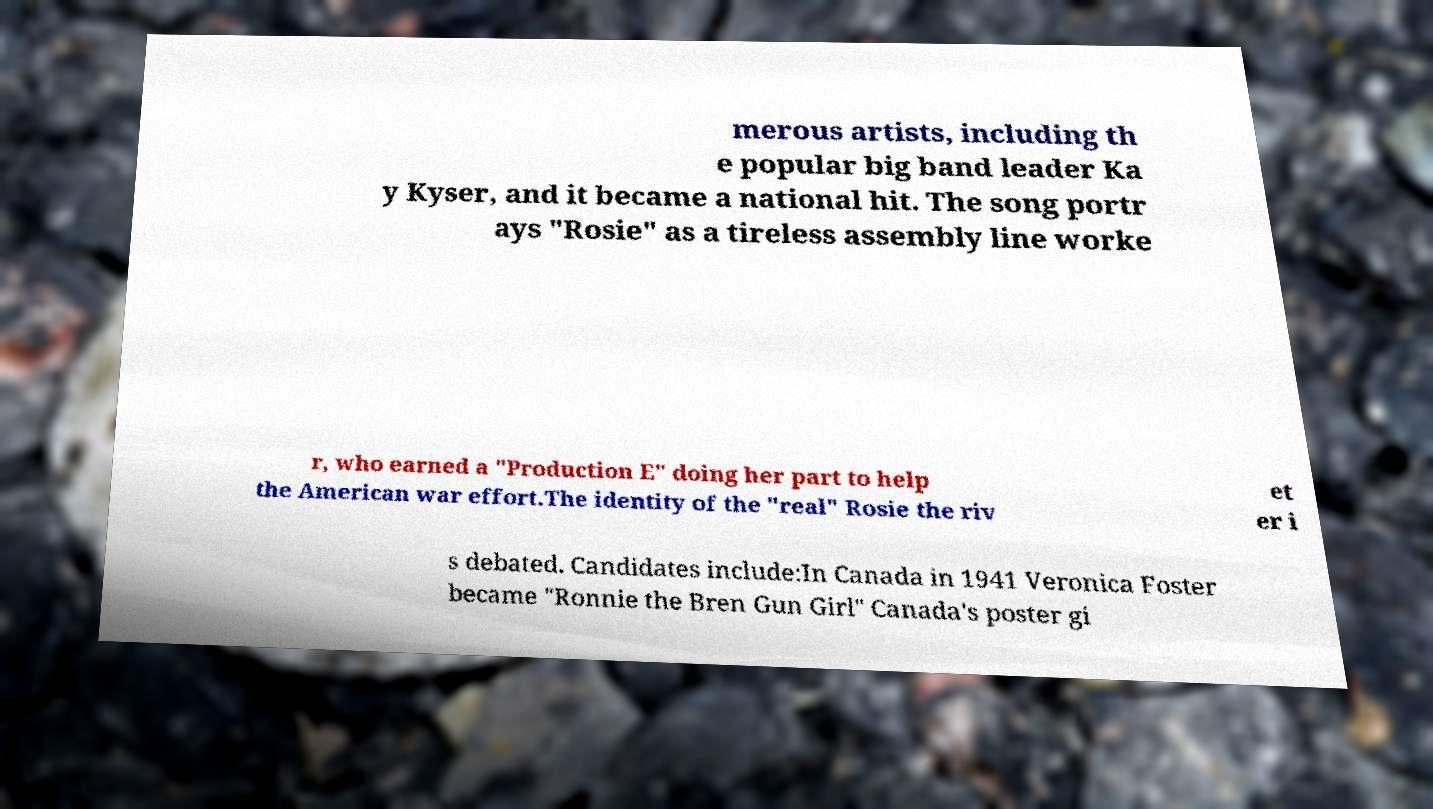Please read and relay the text visible in this image. What does it say? merous artists, including th e popular big band leader Ka y Kyser, and it became a national hit. The song portr ays "Rosie" as a tireless assembly line worke r, who earned a "Production E" doing her part to help the American war effort.The identity of the "real" Rosie the riv et er i s debated. Candidates include:In Canada in 1941 Veronica Foster became "Ronnie the Bren Gun Girl" Canada's poster gi 